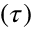Convert formula to latex. <formula><loc_0><loc_0><loc_500><loc_500>( \tau )</formula> 